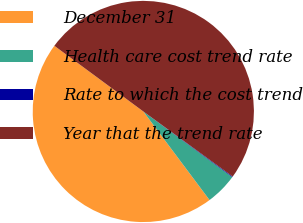Convert chart. <chart><loc_0><loc_0><loc_500><loc_500><pie_chart><fcel>December 31<fcel>Health care cost trend rate<fcel>Rate to which the cost trend<fcel>Year that the trend rate<nl><fcel>45.34%<fcel>4.66%<fcel>0.1%<fcel>49.9%<nl></chart> 